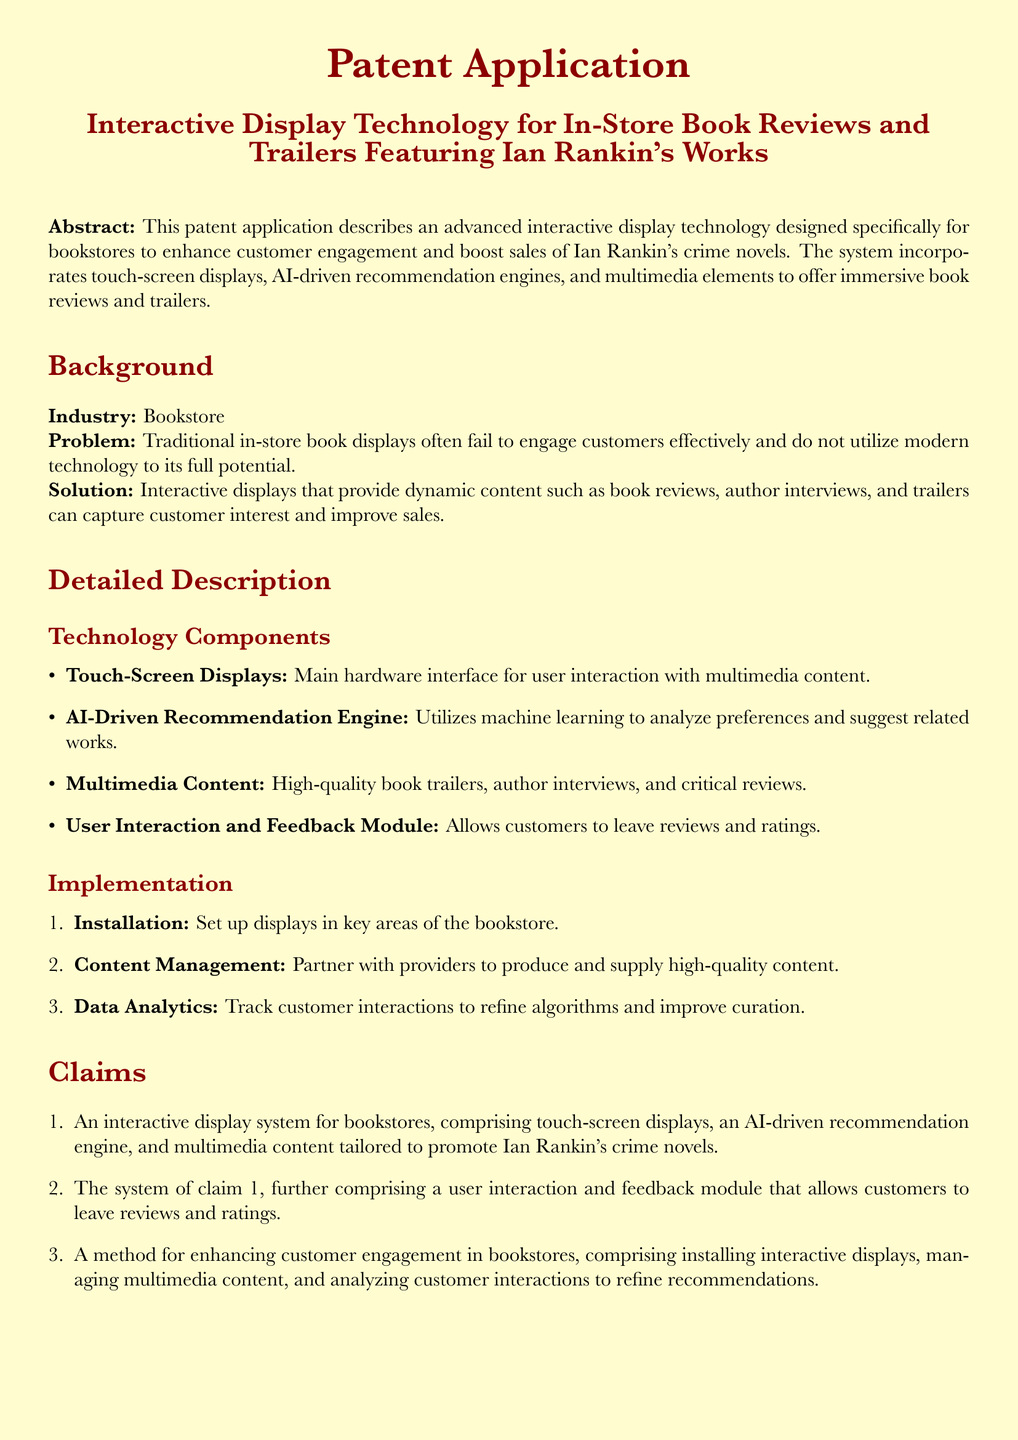What is the title of the patent application? The title of the patent application is explicitly mentioned in the document as "Interactive Display Technology for In-Store Book Reviews and Trailers Featuring Ian Rankin's Works."
Answer: Interactive Display Technology for In-Store Book Reviews and Trailers Featuring Ian Rankin's Works What is the main hardware interface for user interaction? The document specifies the main hardware interface as "Touch-Screen Displays."
Answer: Touch-Screen Displays What technology is used for recommendation in the system? The system utilizes an "AI-Driven Recommendation Engine" for suggestions based on customer preferences.
Answer: AI-Driven Recommendation Engine What is the first claim made in the patent? The first claim is that it outlines "An interactive display system for bookstores, comprising touch-screen displays, an AI-driven recommendation engine, and multimedia content tailored to promote Ian Rankin's crime novels."
Answer: An interactive display system for bookstores, comprising touch-screen displays, an AI-driven recommendation engine, and multimedia content tailored to promote Ian Rankin's crime novels What does the user interaction and feedback module allow customers to do? The module allows customers to "leave reviews and ratings" according to the patent claims section.
Answer: Leave reviews and ratings What is included in the multimedia content as per the document? The multimedia content includes "high-quality book trailers, author interviews, and critical reviews."
Answer: High-quality book trailers, author interviews, and critical reviews What is the purpose of the data analytics mentioned in the document? The purpose of data analytics is to "track customer interactions to refine algorithms and improve curation."
Answer: Track customer interactions to refine algorithms and improve curation What type of industry does this patent application pertain to? The patent application specifically pertains to the "Bookstore" industry as mentioned in the background section.
Answer: Bookstore 